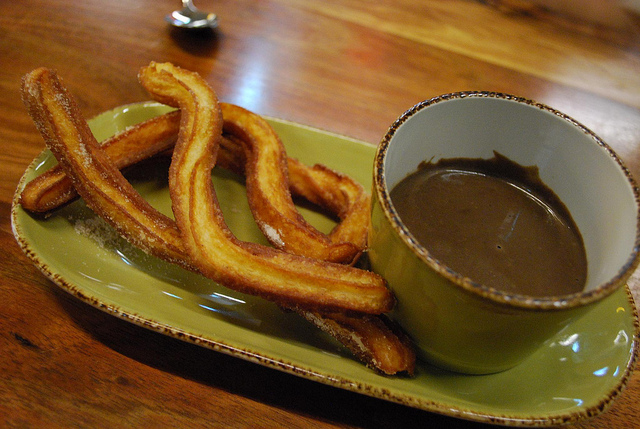Are these sausages? No, these are not sausages. They are churros, a type of fried-dough pastry. 